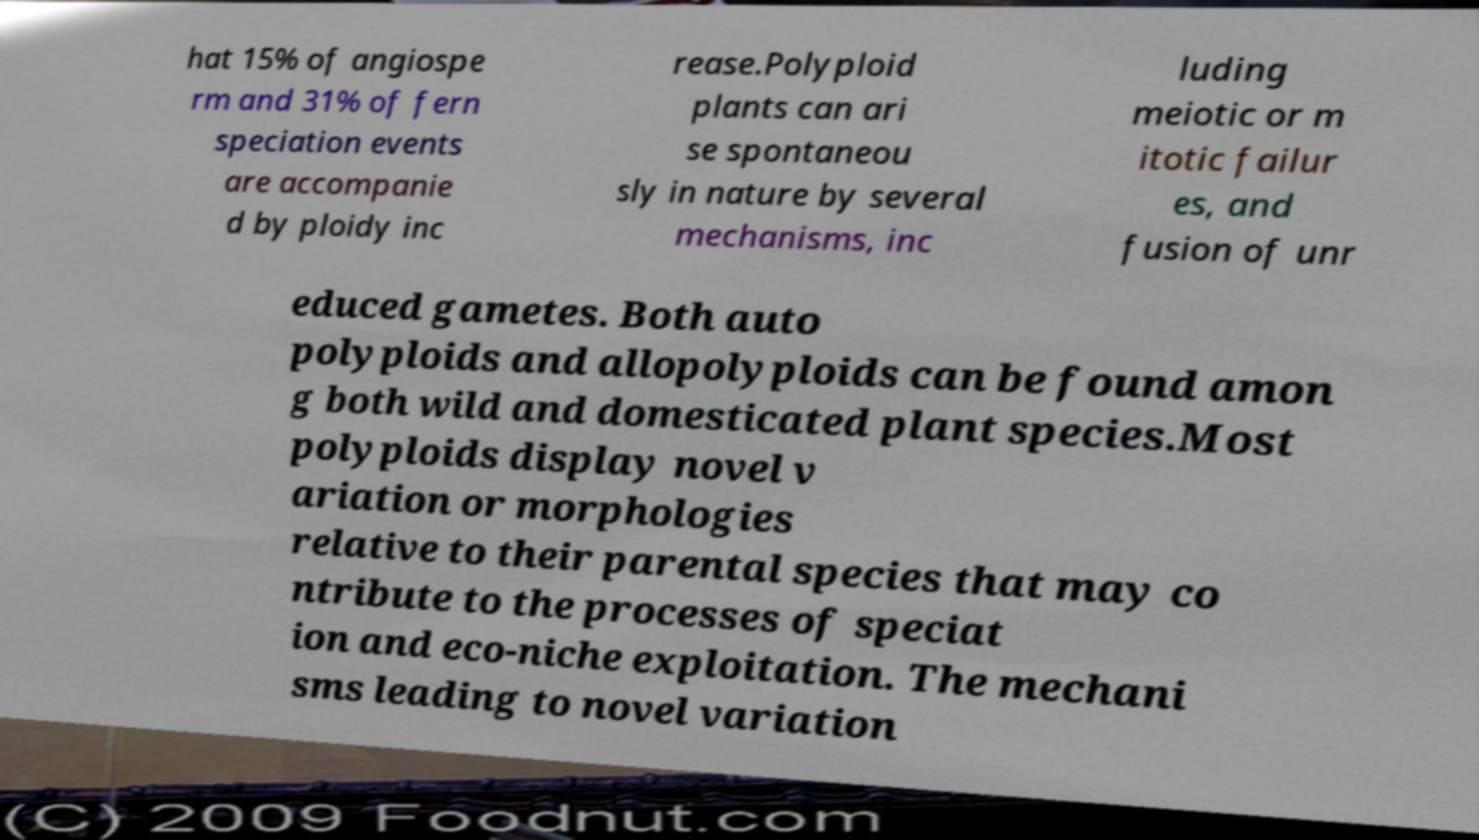There's text embedded in this image that I need extracted. Can you transcribe it verbatim? hat 15% of angiospe rm and 31% of fern speciation events are accompanie d by ploidy inc rease.Polyploid plants can ari se spontaneou sly in nature by several mechanisms, inc luding meiotic or m itotic failur es, and fusion of unr educed gametes. Both auto polyploids and allopolyploids can be found amon g both wild and domesticated plant species.Most polyploids display novel v ariation or morphologies relative to their parental species that may co ntribute to the processes of speciat ion and eco-niche exploitation. The mechani sms leading to novel variation 